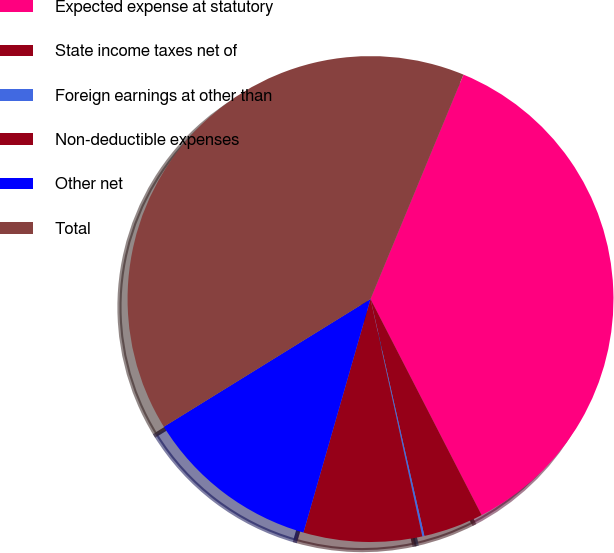Convert chart to OTSL. <chart><loc_0><loc_0><loc_500><loc_500><pie_chart><fcel>Expected expense at statutory<fcel>State income taxes net of<fcel>Foreign earnings at other than<fcel>Non-deductible expenses<fcel>Other net<fcel>Total<nl><fcel>36.19%<fcel>4.0%<fcel>0.14%<fcel>7.87%<fcel>11.74%<fcel>40.06%<nl></chart> 